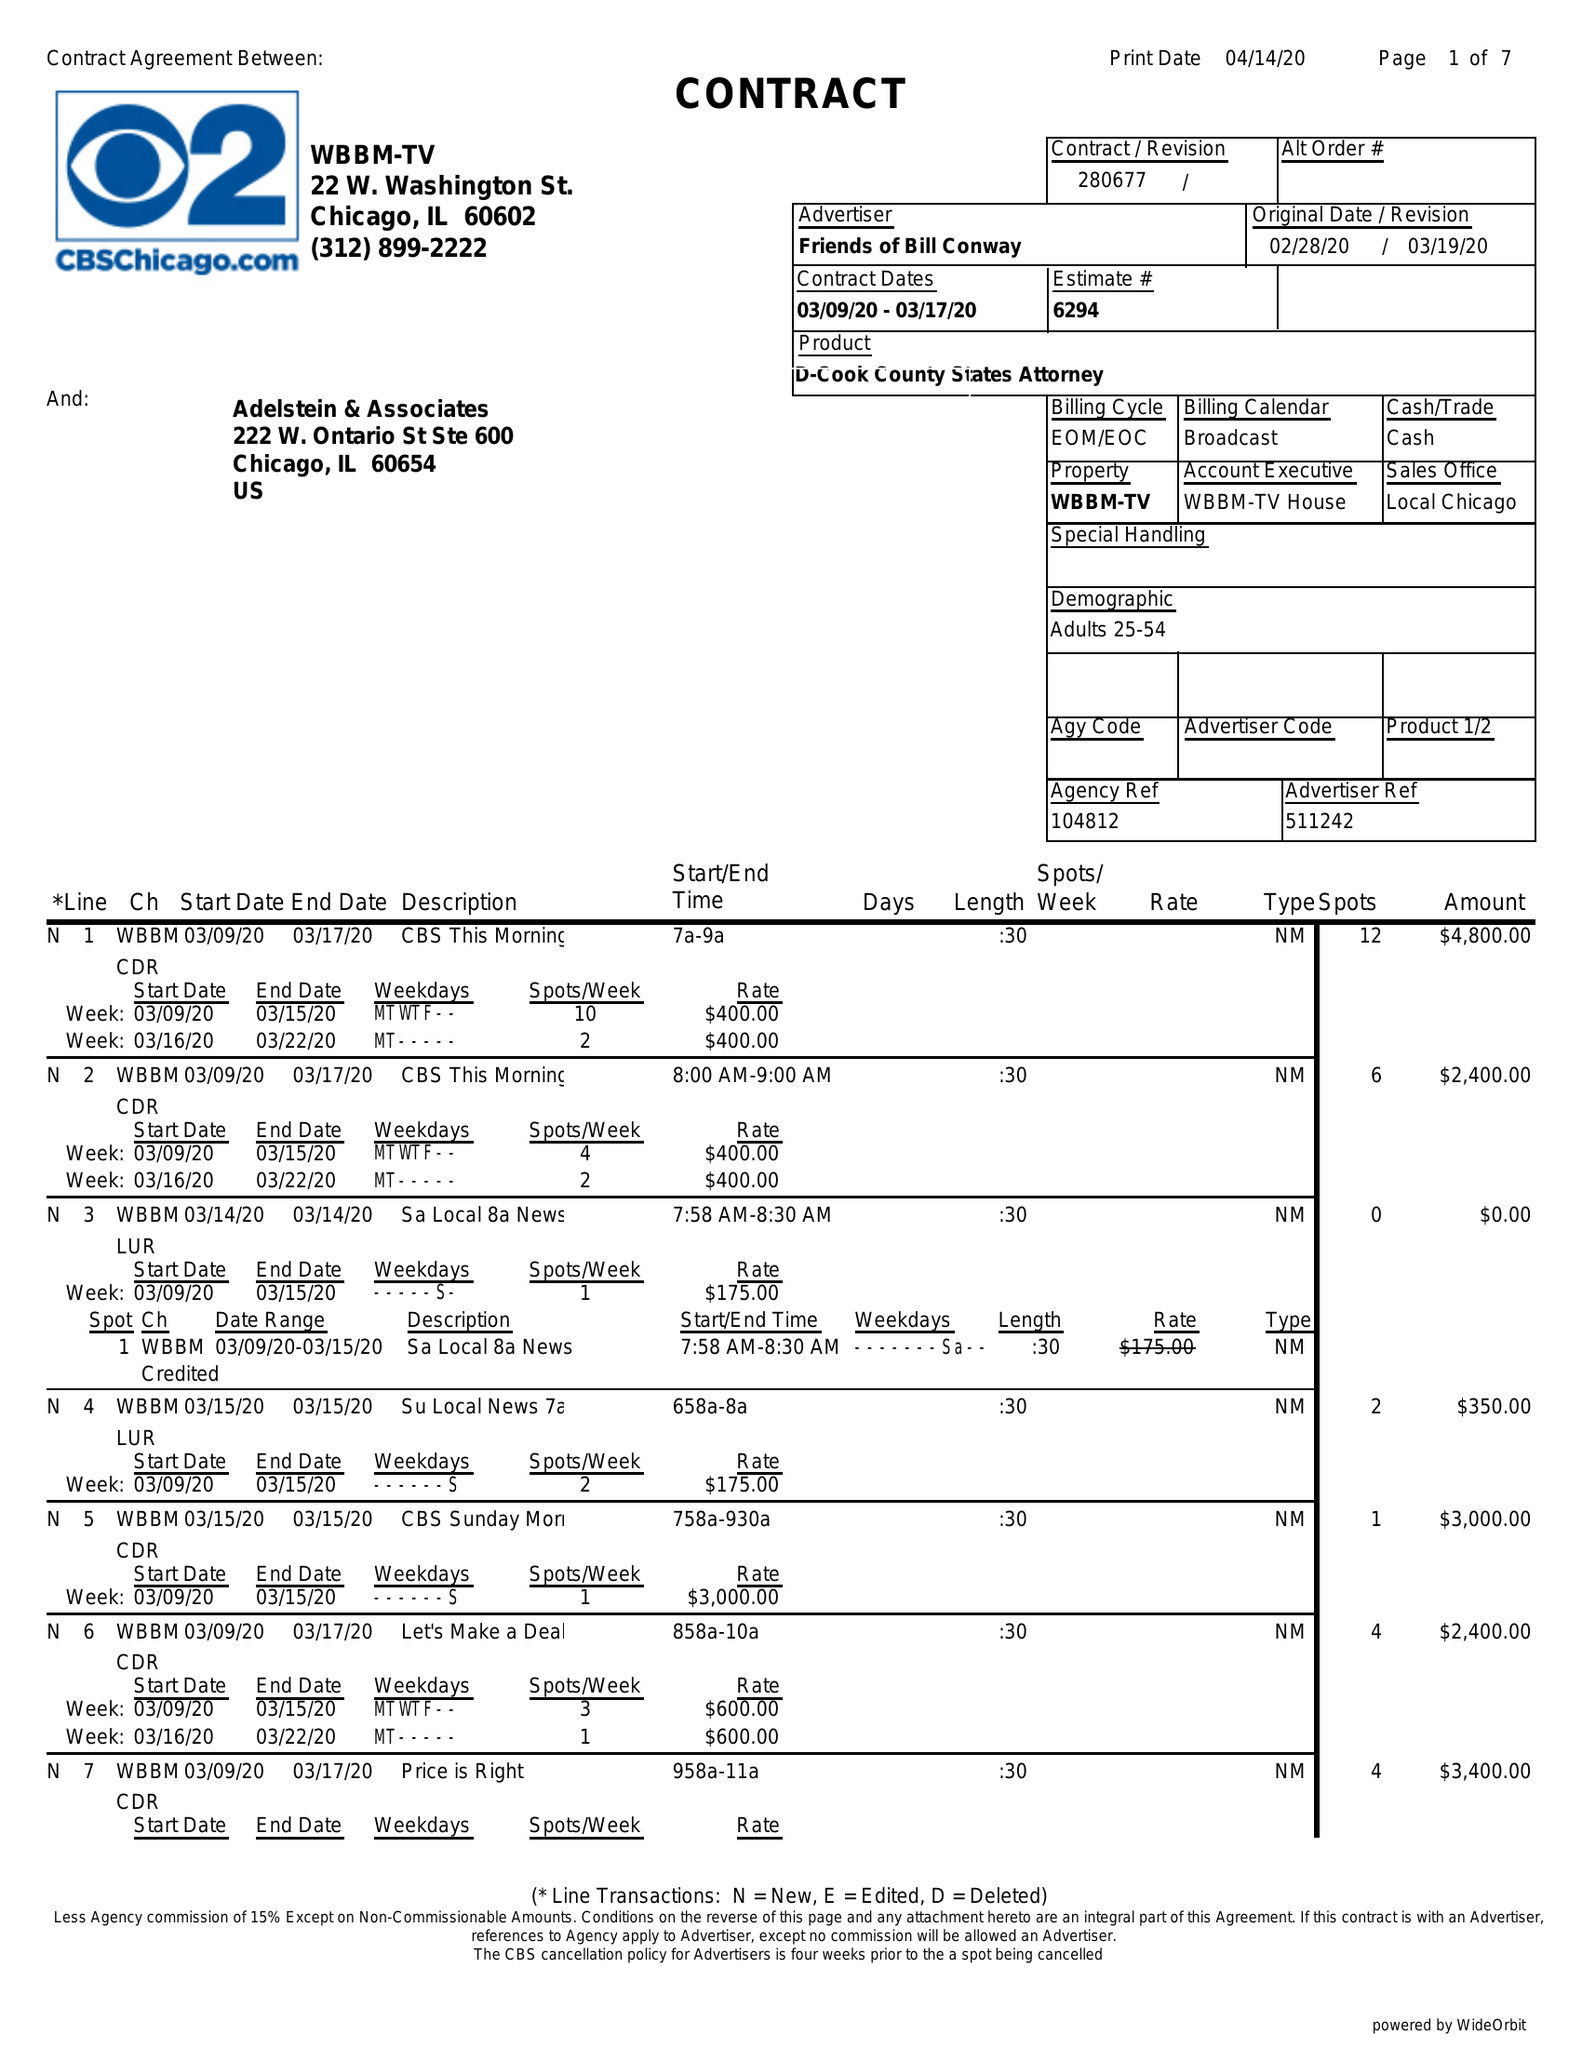What is the value for the contract_num?
Answer the question using a single word or phrase. 280677 